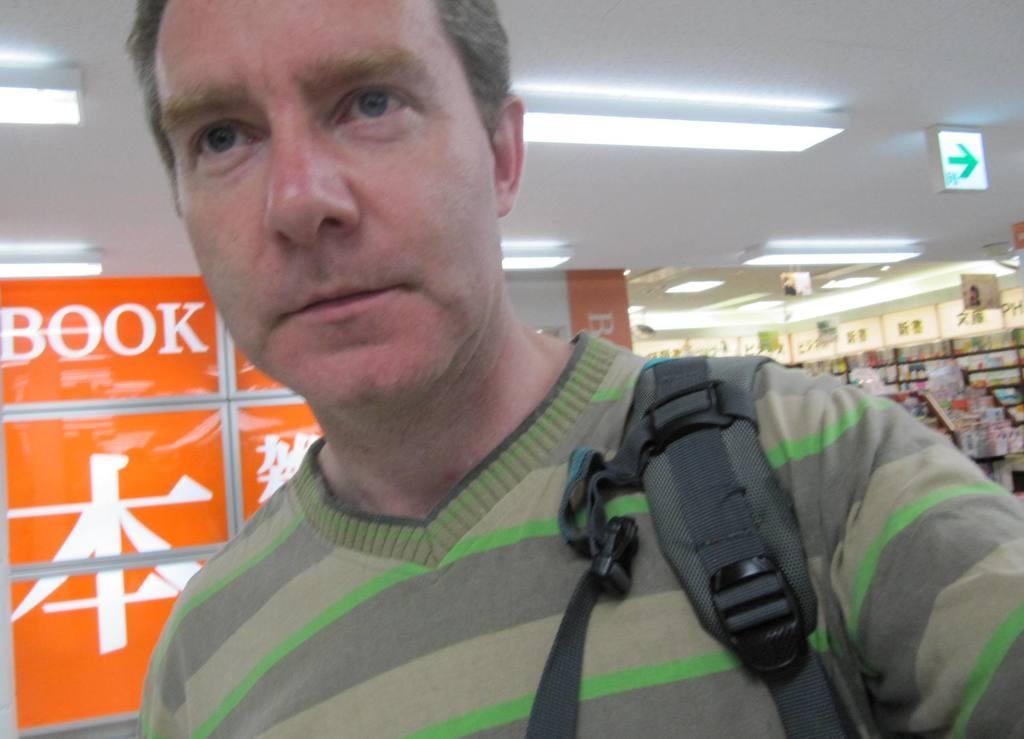Please provide a concise description of this image. This is an inside view. In the foreground, I can see a man wearing t-shirt and hand bag. On the left side, I can see an orange color board which is placed on the floor. In the background there are many objects arranged in the racks. It is looking like a stall. At the top I can see few lights. 